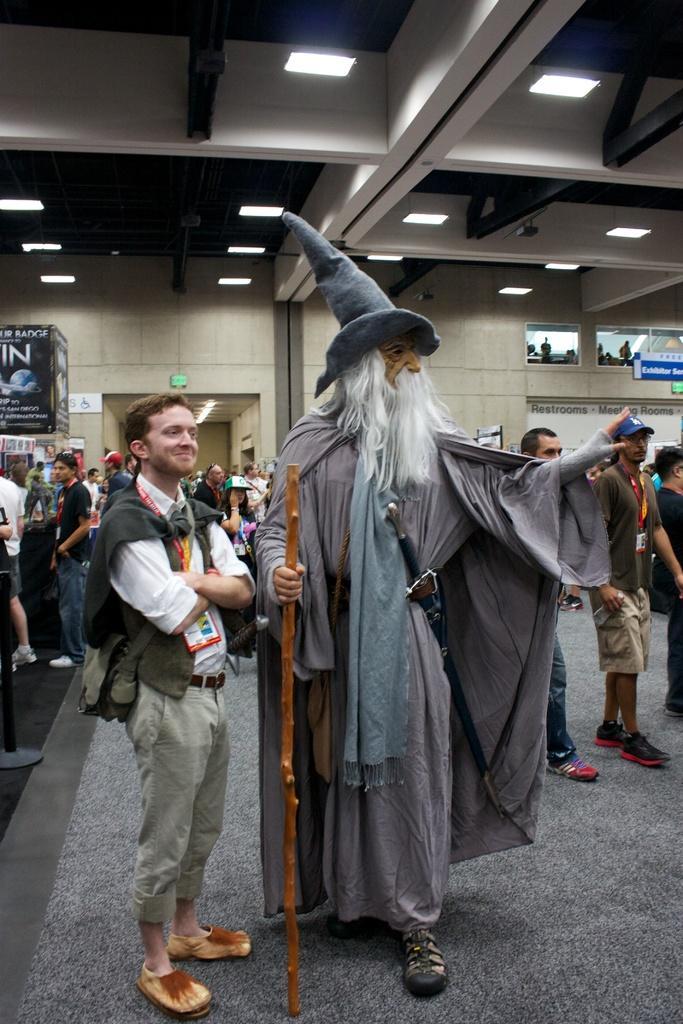Can you describe this image briefly? In this picture we can see a group of people standing on the floor, pole, stick, posters, name board, some objects and in the background we can see the wall, ceiling, lights. 